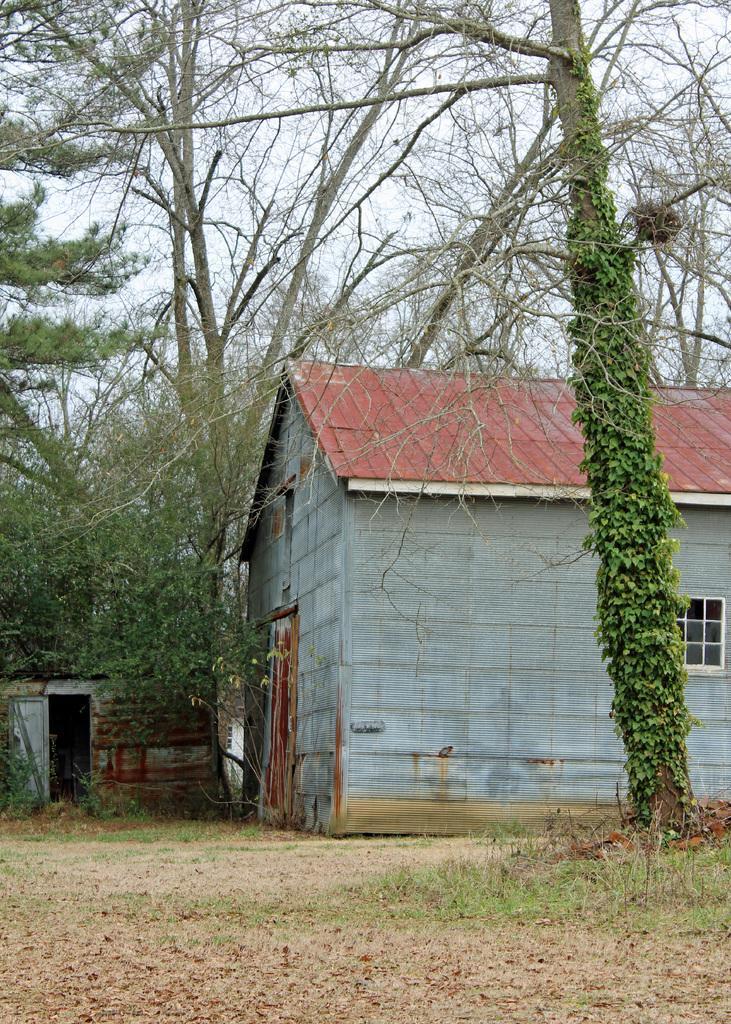Could you give a brief overview of what you see in this image? In this image I can see the ground, some grass on the ground, few trees which are green and ash in color and few houses. I can see the window and in the background I can see the sky. 